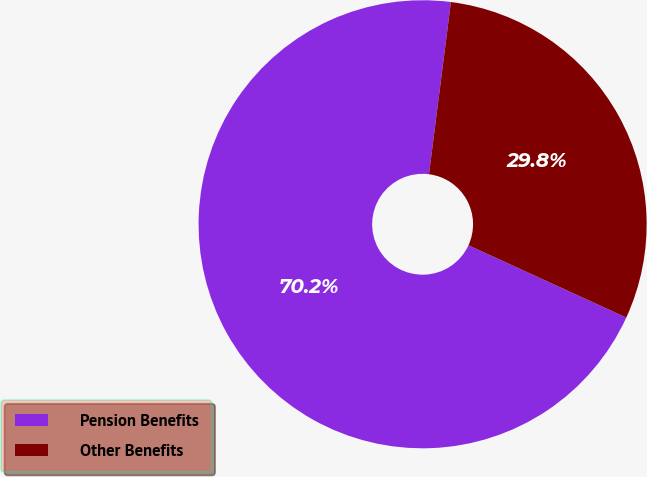<chart> <loc_0><loc_0><loc_500><loc_500><pie_chart><fcel>Pension Benefits<fcel>Other Benefits<nl><fcel>70.18%<fcel>29.82%<nl></chart> 